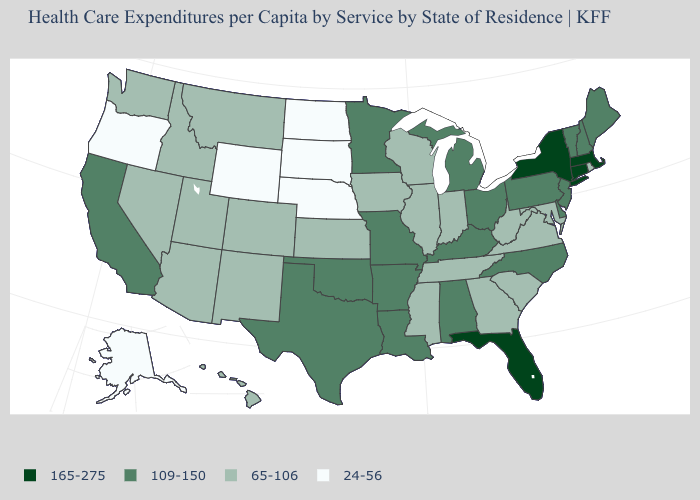Does the map have missing data?
Be succinct. No. Name the states that have a value in the range 165-275?
Answer briefly. Connecticut, Florida, Massachusetts, New York. Is the legend a continuous bar?
Write a very short answer. No. Which states have the lowest value in the USA?
Answer briefly. Alaska, Nebraska, North Dakota, Oregon, South Dakota, Wyoming. What is the value of New Hampshire?
Write a very short answer. 109-150. Name the states that have a value in the range 65-106?
Concise answer only. Arizona, Colorado, Georgia, Hawaii, Idaho, Illinois, Indiana, Iowa, Kansas, Maryland, Mississippi, Montana, Nevada, New Mexico, Rhode Island, South Carolina, Tennessee, Utah, Virginia, Washington, West Virginia, Wisconsin. Name the states that have a value in the range 165-275?
Quick response, please. Connecticut, Florida, Massachusetts, New York. Which states have the lowest value in the USA?
Short answer required. Alaska, Nebraska, North Dakota, Oregon, South Dakota, Wyoming. Name the states that have a value in the range 109-150?
Answer briefly. Alabama, Arkansas, California, Delaware, Kentucky, Louisiana, Maine, Michigan, Minnesota, Missouri, New Hampshire, New Jersey, North Carolina, Ohio, Oklahoma, Pennsylvania, Texas, Vermont. What is the value of Mississippi?
Quick response, please. 65-106. What is the value of Georgia?
Write a very short answer. 65-106. What is the lowest value in the MidWest?
Write a very short answer. 24-56. What is the value of Rhode Island?
Concise answer only. 65-106. What is the value of Oregon?
Give a very brief answer. 24-56. Name the states that have a value in the range 165-275?
Short answer required. Connecticut, Florida, Massachusetts, New York. 